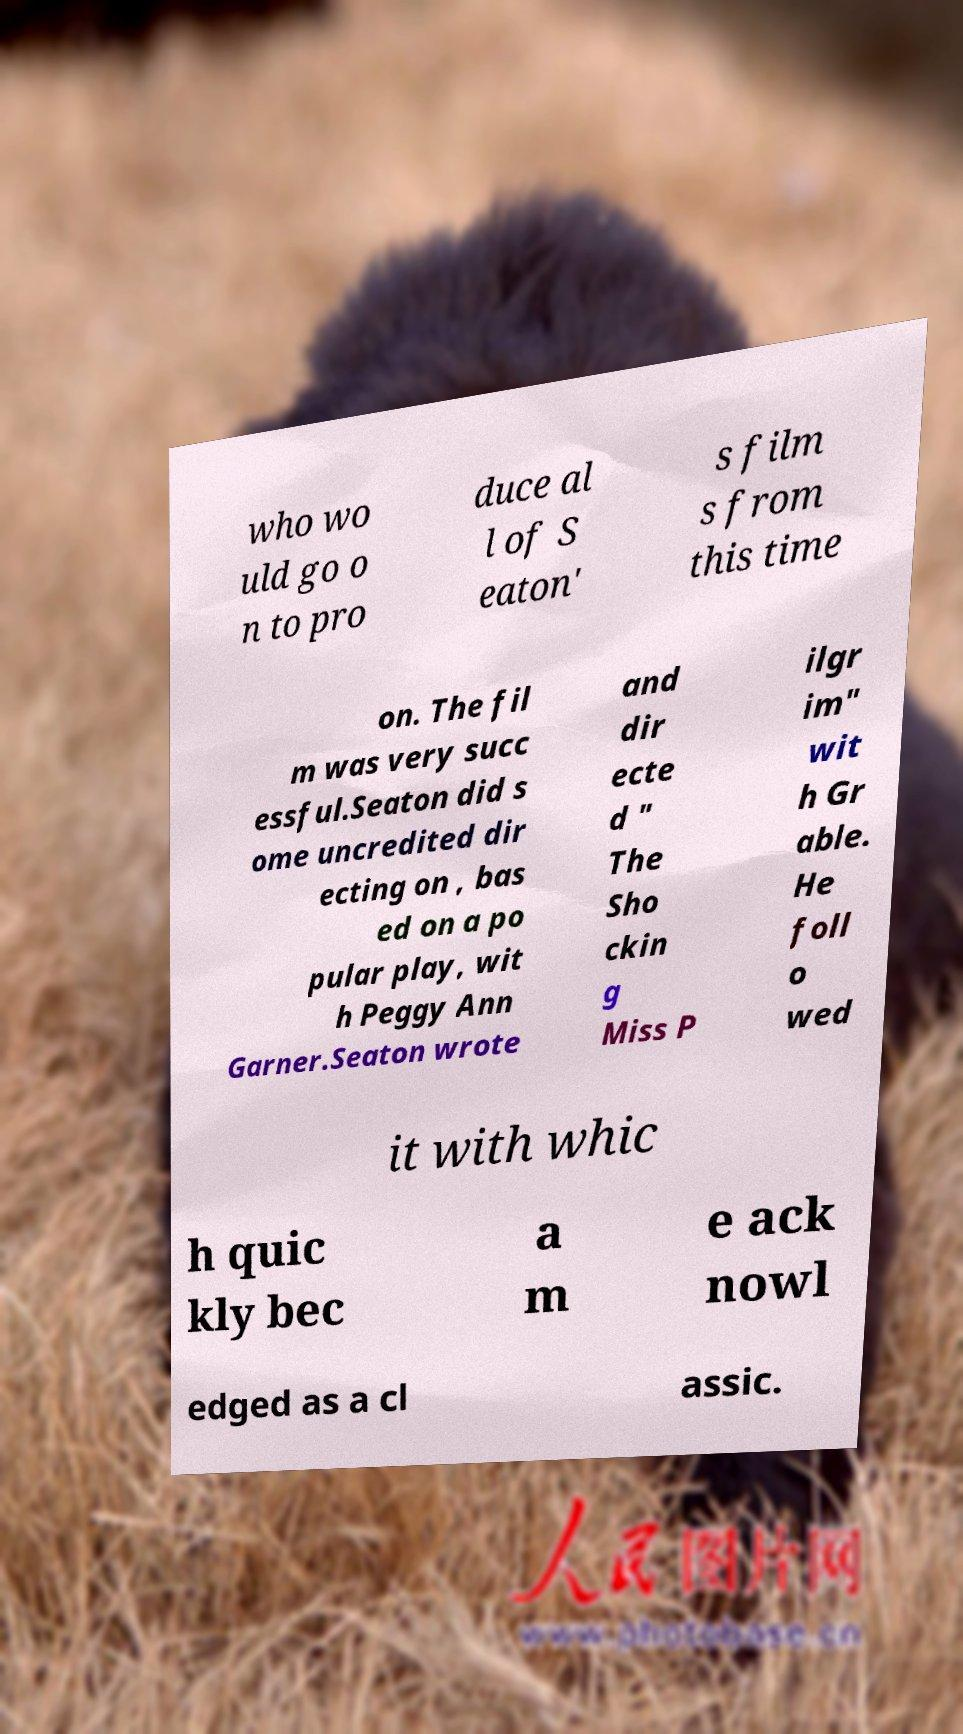I need the written content from this picture converted into text. Can you do that? who wo uld go o n to pro duce al l of S eaton' s film s from this time on. The fil m was very succ essful.Seaton did s ome uncredited dir ecting on , bas ed on a po pular play, wit h Peggy Ann Garner.Seaton wrote and dir ecte d " The Sho ckin g Miss P ilgr im" wit h Gr able. He foll o wed it with whic h quic kly bec a m e ack nowl edged as a cl assic. 